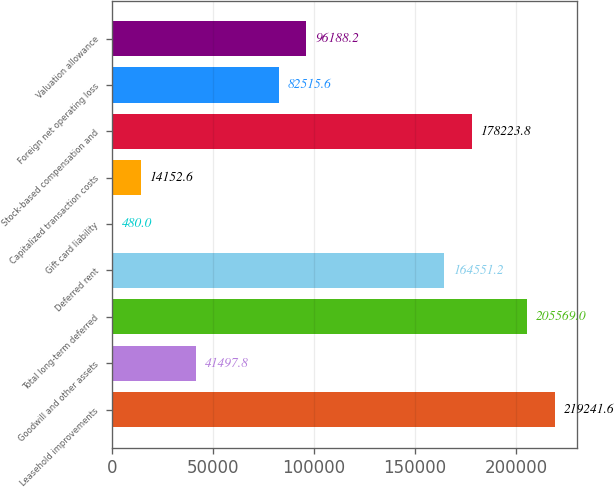Convert chart to OTSL. <chart><loc_0><loc_0><loc_500><loc_500><bar_chart><fcel>Leasehold improvements<fcel>Goodwill and other assets<fcel>Total long-term deferred<fcel>Deferred rent<fcel>Gift card liability<fcel>Capitalized transaction costs<fcel>Stock-based compensation and<fcel>Foreign net operating loss<fcel>Valuation allowance<nl><fcel>219242<fcel>41497.8<fcel>205569<fcel>164551<fcel>480<fcel>14152.6<fcel>178224<fcel>82515.6<fcel>96188.2<nl></chart> 